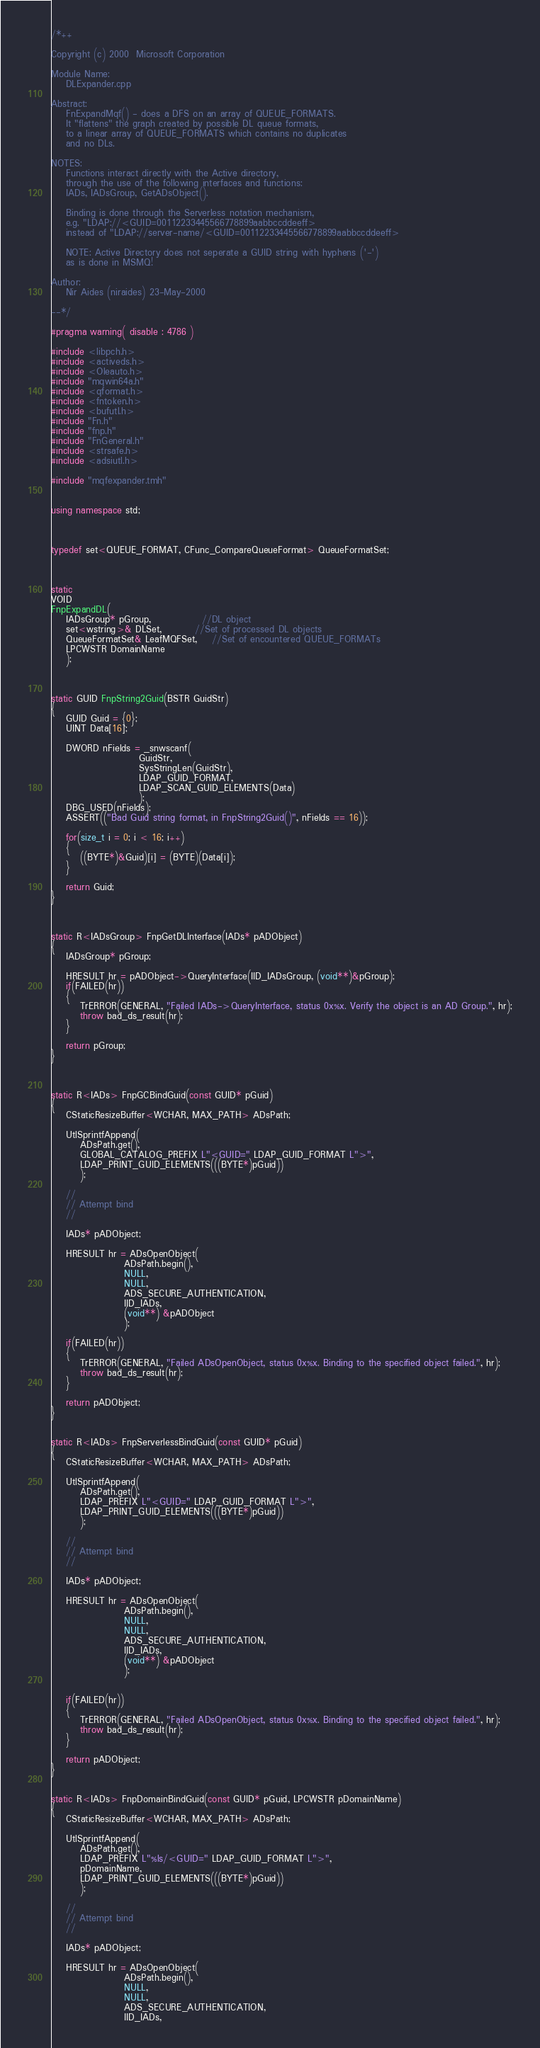Convert code to text. <code><loc_0><loc_0><loc_500><loc_500><_C++_>/*++

Copyright (c) 2000  Microsoft Corporation

Module Name:
    DLExpander.cpp

Abstract:
    FnExpandMqf() - does a DFS on an array of QUEUE_FORMATS.
	It "flattens" the graph created by possible DL queue formats, 
	to a linear array of QUEUE_FORMATS which contains no duplicates 
	and no DLs.

NOTES:
	Functions interact directly with the Active directory,
	through the use of the following interfaces and functions:
	IADs, IADsGroup, GetADsObject().

	Binding is done through the Serverless notation mechanism,
	e.g. "LDAP://<GUID=00112233445566778899aabbccddeeff>
	instead of "LDAP://server-name/<GUID=00112233445566778899aabbccddeeff>

	NOTE: Active Directory does not seperate a GUID string with hyphens ('-')
	as is done in MSMQ!

Author:
    Nir Aides (niraides) 23-May-2000

--*/

#pragma warning( disable : 4786 )

#include <libpch.h>
#include <activeds.h>
#include <Oleauto.h>
#include "mqwin64a.h"
#include <qformat.h>
#include <fntoken.h>
#include <bufutl.h>
#include "Fn.h"
#include "fnp.h"
#include "FnGeneral.h"
#include <strsafe.h>
#include <adsiutl.h>

#include "mqfexpander.tmh"


using namespace std;



typedef set<QUEUE_FORMAT, CFunc_CompareQueueFormat> QueueFormatSet;



static
VOID 
FnpExpandDL(
	IADsGroup* pGroup,			  //DL object
	set<wstring>& DLSet,		 //Set of processed DL objects
	QueueFormatSet& LeafMQFSet,	//Set of encountered QUEUE_FORMATs
	LPCWSTR DomainName
	);



static GUID FnpString2Guid(BSTR GuidStr)
{
    GUID Guid = {0};
	UINT Data[16];

    DWORD nFields = _snwscanf(
						GuidStr,
						SysStringLen(GuidStr),
						LDAP_GUID_FORMAT,
						LDAP_SCAN_GUID_ELEMENTS(Data)
						);    
    DBG_USED(nFields);
    ASSERT(("Bad Guid string format, in FnpString2Guid()", nFields == 16));
    
	for(size_t i = 0; i < 16; i++)
	{
		((BYTE*)&Guid)[i] = (BYTE)(Data[i]);
	}

	return Guid;
}



static R<IADsGroup> FnpGetDLInterface(IADs* pADObject)
{
	IADsGroup* pGroup;

	HRESULT hr = pADObject->QueryInterface(IID_IADsGroup, (void**)&pGroup);
	if(FAILED(hr))
	{
        TrERROR(GENERAL, "Failed IADs->QueryInterface, status 0x%x. Verify the object is an AD Group.", hr);
        throw bad_ds_result(hr);
	}

	return pGroup;
}


			
static R<IADs> FnpGCBindGuid(const GUID* pGuid)
{
	CStaticResizeBuffer<WCHAR, MAX_PATH> ADsPath;

	UtlSprintfAppend(
		ADsPath.get(),
		GLOBAL_CATALOG_PREFIX L"<GUID=" LDAP_GUID_FORMAT L">",
		LDAP_PRINT_GUID_ELEMENTS(((BYTE*)pGuid))
		);
		
	//
	// Attempt bind
	// 

	IADs* pADObject;
	
	HRESULT hr = ADsOpenObject( 
					ADsPath.begin(),
					NULL,
					NULL,
					ADS_SECURE_AUTHENTICATION,
					IID_IADs,
					(void**) &pADObject
					);

    if(FAILED(hr))
	{
        TrERROR(GENERAL, "Failed ADsOpenObject, status 0x%x. Binding to the specified object failed.", hr);
		throw bad_ds_result(hr);
	}

	return pADObject;
}

			
static R<IADs> FnpServerlessBindGuid(const GUID* pGuid)
{
	CStaticResizeBuffer<WCHAR, MAX_PATH> ADsPath;

	UtlSprintfAppend(
		ADsPath.get(),
		LDAP_PREFIX L"<GUID=" LDAP_GUID_FORMAT L">",
		LDAP_PRINT_GUID_ELEMENTS(((BYTE*)pGuid))
		);
		
	//
	// Attempt bind
	// 

	IADs* pADObject;
	
	HRESULT hr = ADsOpenObject( 
					ADsPath.begin(),
					NULL,
					NULL,
					ADS_SECURE_AUTHENTICATION,
					IID_IADs,
					(void**) &pADObject
					);


    if(FAILED(hr))
	{
        TrERROR(GENERAL, "Failed ADsOpenObject, status 0x%x. Binding to the specified object failed.", hr);
		throw bad_ds_result(hr);
	}

	return pADObject;
}

			
static R<IADs> FnpDomainBindGuid(const GUID* pGuid, LPCWSTR pDomainName)
{
	CStaticResizeBuffer<WCHAR, MAX_PATH> ADsPath;

	UtlSprintfAppend(
		ADsPath.get(),
		LDAP_PREFIX L"%ls/<GUID=" LDAP_GUID_FORMAT L">",
		pDomainName,
		LDAP_PRINT_GUID_ELEMENTS(((BYTE*)pGuid))
		);
		
	//
	// Attempt bind
	// 

	IADs* pADObject;
	
	HRESULT hr = ADsOpenObject( 
					ADsPath.begin(),
					NULL,
					NULL,
					ADS_SECURE_AUTHENTICATION,
					IID_IADs,</code> 